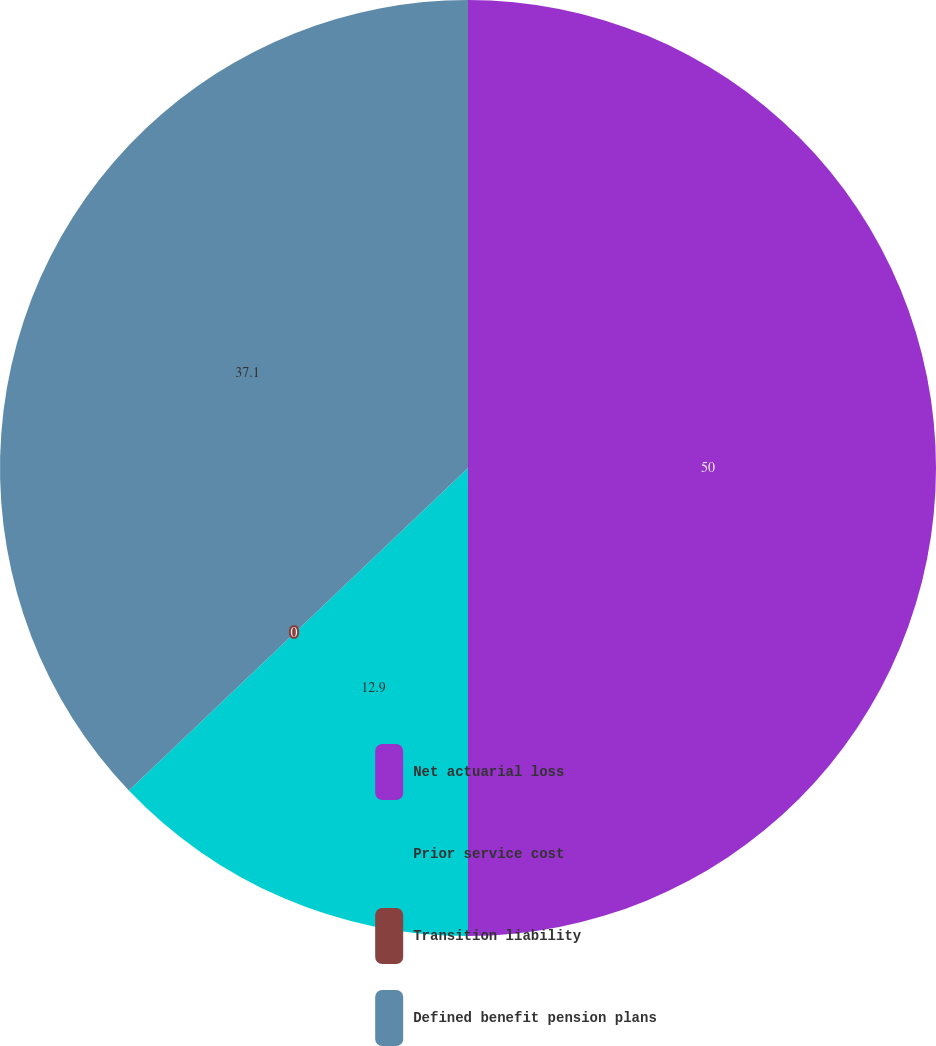Convert chart. <chart><loc_0><loc_0><loc_500><loc_500><pie_chart><fcel>Net actuarial loss<fcel>Prior service cost<fcel>Transition liability<fcel>Defined benefit pension plans<nl><fcel>50.0%<fcel>12.9%<fcel>0.0%<fcel>37.1%<nl></chart> 